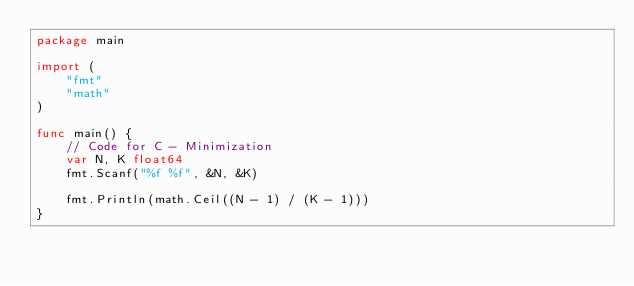<code> <loc_0><loc_0><loc_500><loc_500><_Go_>package main

import (
	"fmt"
	"math"
)

func main() {
	// Code for C - Minimization
	var N, K float64
	fmt.Scanf("%f %f", &N, &K)

	fmt.Println(math.Ceil((N - 1) / (K - 1)))
}
</code> 